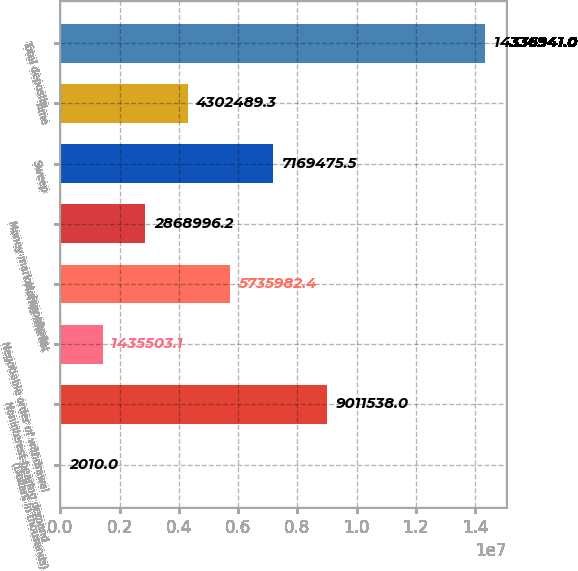Convert chart. <chart><loc_0><loc_0><loc_500><loc_500><bar_chart><fcel>(Dollars in thousands)<fcel>Noninterest-bearing demand<fcel>Negotiable order of withdrawal<fcel>Money market<fcel>Money market deposits in<fcel>Sweep<fcel>Time<fcel>Total deposits<nl><fcel>2010<fcel>9.01154e+06<fcel>1.4355e+06<fcel>5.73598e+06<fcel>2.869e+06<fcel>7.16948e+06<fcel>4.30249e+06<fcel>1.43369e+07<nl></chart> 